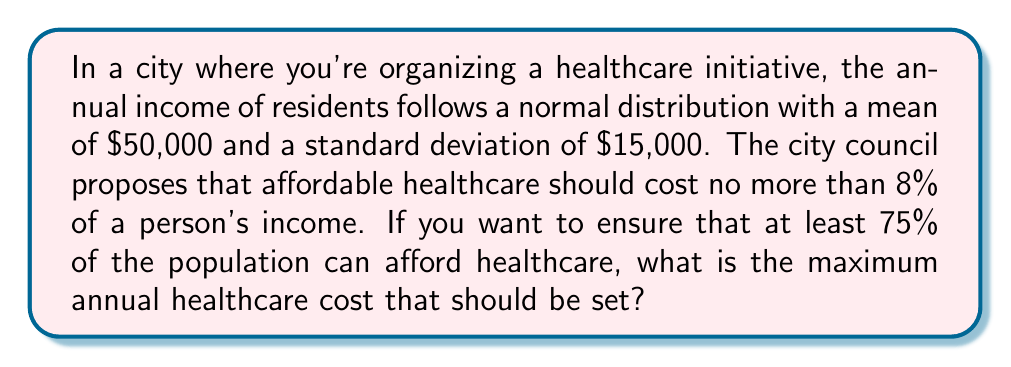Help me with this question. Let's approach this step-by-step:

1) First, we need to find the z-score that corresponds to the 25th percentile (because we want 75% of the population to afford healthcare, which means we're looking at the lower 75%).

   The z-score for the 25th percentile is -0.67 (from a standard normal distribution table).

2) Now, we can use the z-score formula to find the income at this percentile:

   $$ z = \frac{x - \mu}{\sigma} $$

   Where:
   $z = -0.67$
   $\mu = 50,000$ (mean income)
   $\sigma = 15,000$ (standard deviation of income)

3) Substituting these values:

   $$ -0.67 = \frac{x - 50,000}{15,000} $$

4) Solving for x:

   $$ -0.67 * 15,000 = x - 50,000 $$
   $$ -10,050 = x - 50,000 $$
   $$ x = 39,950 $$

5) This means that 25% of the population earns $39,950 or less annually.

6) The maximum healthcare cost should be 8% of this income:

   $$ 39,950 * 0.08 = 3,196 $$

Therefore, the maximum annual healthcare cost should be set at $3,196 to ensure that at least 75% of the population can afford it.
Answer: $3,196 